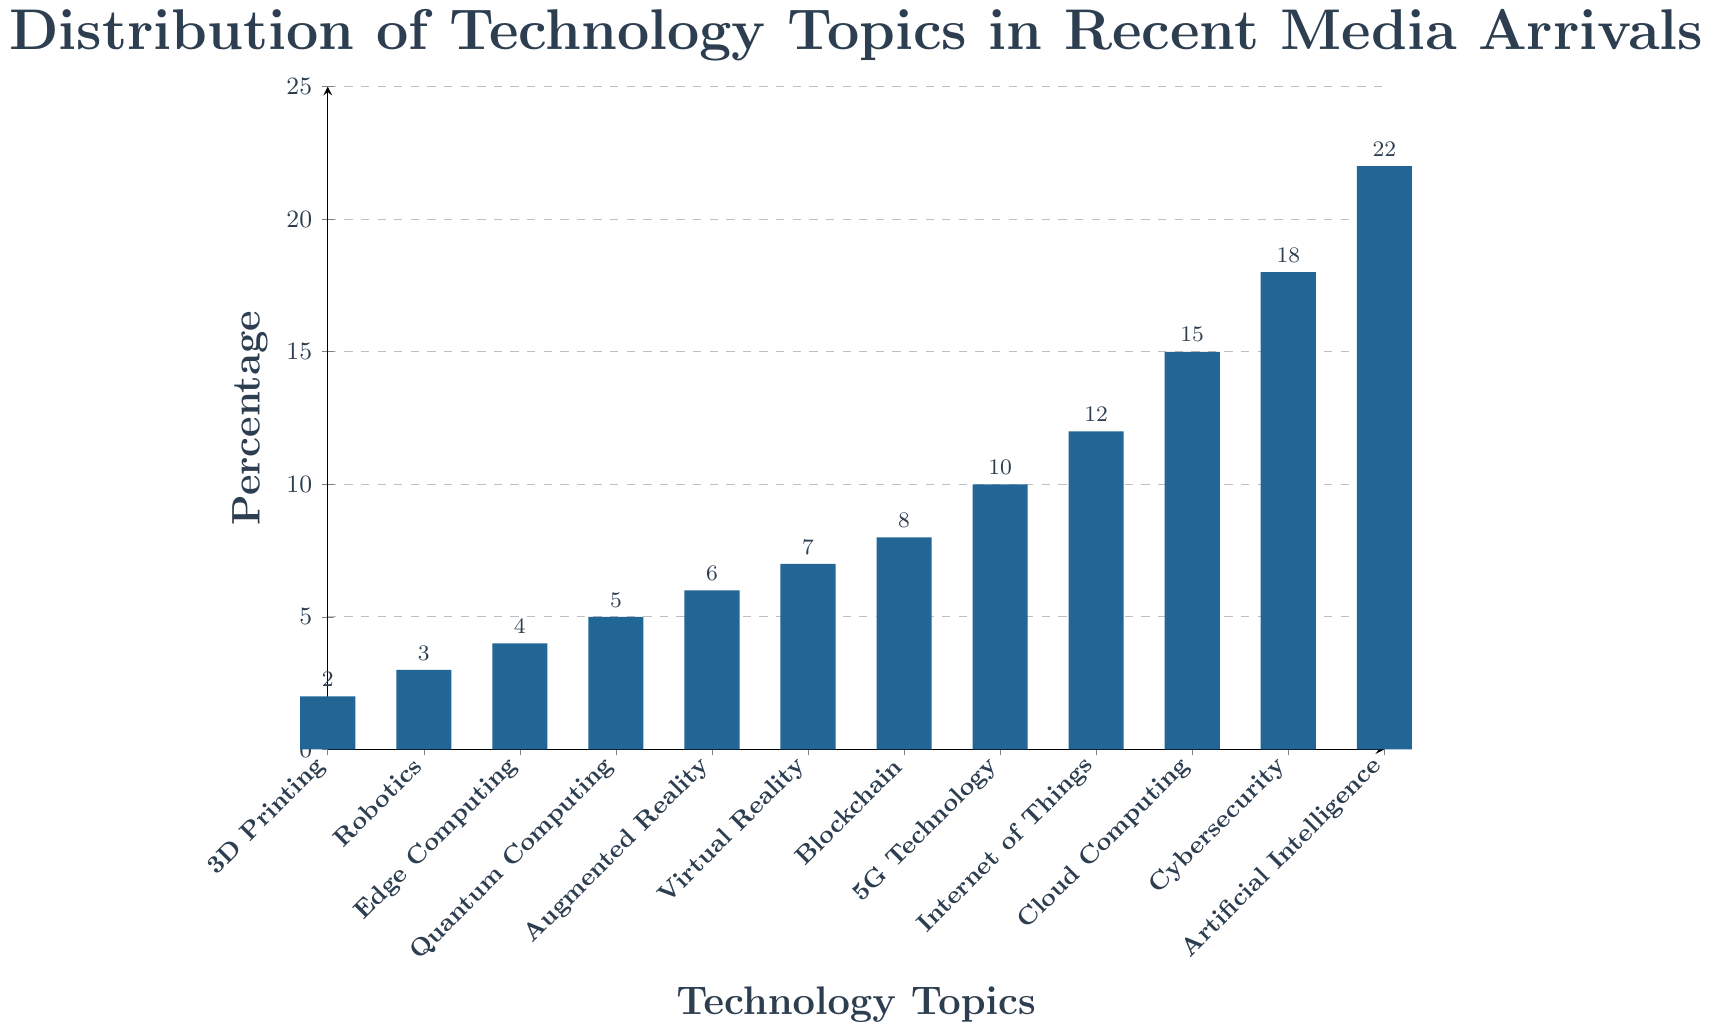what is the most covered technology topic in recent media arrivals? Look at the bar chart and find the tallest bar. The tallest bar represents Artificial Intelligence, which has the highest percentage.
Answer: Artificial Intelligence Which two topics have the same proportion? Observation of the bars shows that "Quantum Computing" and "Edge Computing" have almost the same bar height, both at around 5%.
Answer: None What is the total percentage of coverage for Cybersecurity, Cloud Computing, and Internet of Things? Find the bars representing these topics and add their percentages: 18 (Cybersecurity) + 15 (Cloud Computing) + 12 (Internet of Things) = 45%.
Answer: 45% Which topic has a higher percentage: Blockchain or Augmented Reality? Compare the heights of the bars for Blockchain (8%) and Augmented Reality (6%). Blockchain has a higher percentage.
Answer: Blockchain What visual color is used for the bars in the chart? The bars are colored in a specific shade as seen in the chart. The visual attribute of the bars is a shade of blue.
Answer: Blue What percentage do the three least covered topics contribute together? Add percentages of the three shortest bars: 3D Printing (2%), Robotics (3%), and Edge Computing (4%), which together is 2+3+4=9%.
Answer: 9% By how much does the percentage of Artificial Intelligence exceed that of 5G Technology? Subtract the percentage of 5G Technology (10%) from Artificial Intelligence (22%): 22-10=12%.
Answer: 12% What's the combined percentage of Emerging technologies like Quantum Computing, Edge Computing, and 3D Printing? Sum up the percentages: Quantum Computing (5%) + Edge Computing (4%) + 3D Printing (2%) = 11%.
Answer: 11% Which topic has the lowest coverage percentage, and what is its value? Look for the shortest bar in the chart, which represents 3D Printing with a value of 2%.
Answer: 3D Printing, 2% How does the coverage of Virtual Reality compare to that of Augmented Reality? Compare the percentage of Virtual Reality (7%) and Augmented Reality (6%). Virtual Reality has a higher percentage by 1%.
Answer: Virtual Reality by 1% 